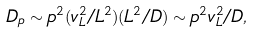<formula> <loc_0><loc_0><loc_500><loc_500>D _ { p } \sim p ^ { 2 } ( v _ { L } ^ { 2 } / L ^ { 2 } ) ( L ^ { 2 } / D ) \sim p ^ { 2 } v _ { L } ^ { 2 } / D ,</formula> 